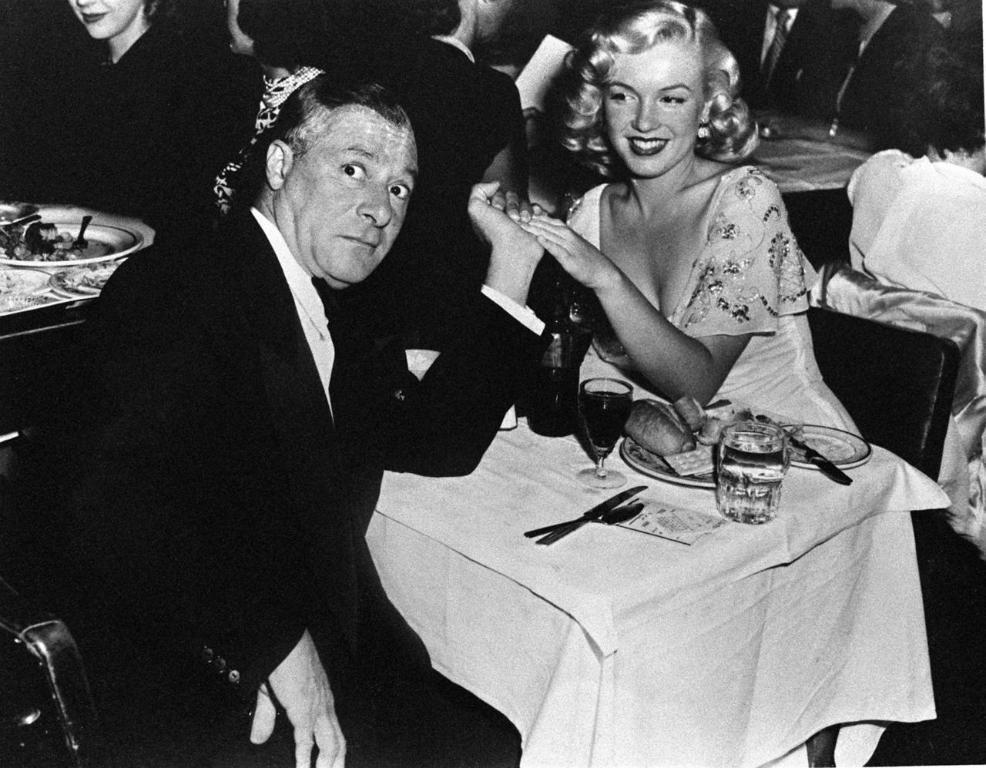How would you summarize this image in a sentence or two? This is black and white picture, in this picture there are people and we can see glasses, plates, food, knifes and objects on tables and we can see chairs. 